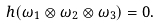<formula> <loc_0><loc_0><loc_500><loc_500>h ( \omega _ { 1 } \otimes \omega _ { 2 } \otimes \omega _ { 3 } ) = 0 .</formula> 